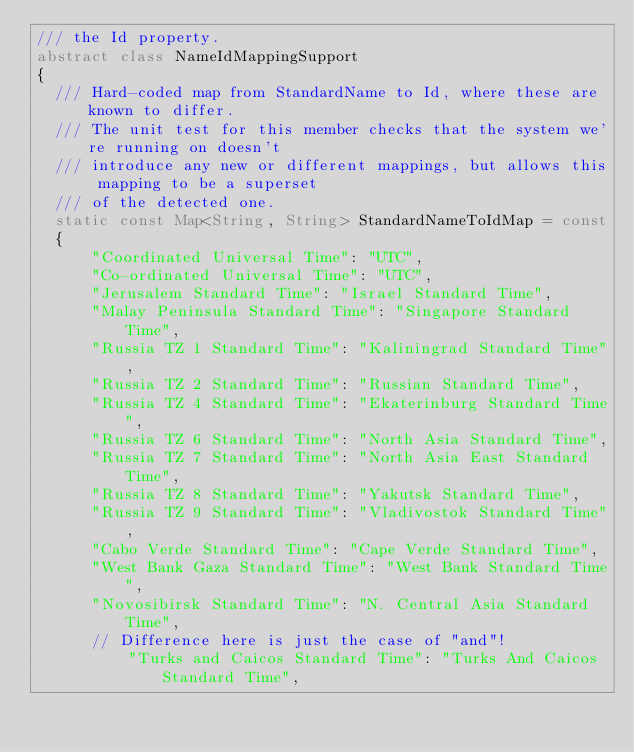Convert code to text. <code><loc_0><loc_0><loc_500><loc_500><_Dart_>/// the Id property.
abstract class NameIdMappingSupport
{
  /// Hard-coded map from StandardName to Id, where these are known to differ.
  /// The unit test for this member checks that the system we're running on doesn't
  /// introduce any new or different mappings, but allows this mapping to be a superset
  /// of the detected one.
  static const Map<String, String> StandardNameToIdMap = const
  {
      "Coordinated Universal Time": "UTC",
      "Co-ordinated Universal Time": "UTC",
      "Jerusalem Standard Time": "Israel Standard Time",
      "Malay Peninsula Standard Time": "Singapore Standard Time",
      "Russia TZ 1 Standard Time": "Kaliningrad Standard Time",
      "Russia TZ 2 Standard Time": "Russian Standard Time",
      "Russia TZ 4 Standard Time": "Ekaterinburg Standard Time",
      "Russia TZ 6 Standard Time": "North Asia Standard Time",
      "Russia TZ 7 Standard Time": "North Asia East Standard Time",
      "Russia TZ 8 Standard Time": "Yakutsk Standard Time",
      "Russia TZ 9 Standard Time": "Vladivostok Standard Time",
      "Cabo Verde Standard Time": "Cape Verde Standard Time",
      "West Bank Gaza Standard Time": "West Bank Standard Time",
      "Novosibirsk Standard Time": "N. Central Asia Standard Time",
      // Difference here is just the case of "and"!
          "Turks and Caicos Standard Time": "Turks And Caicos Standard Time",</code> 